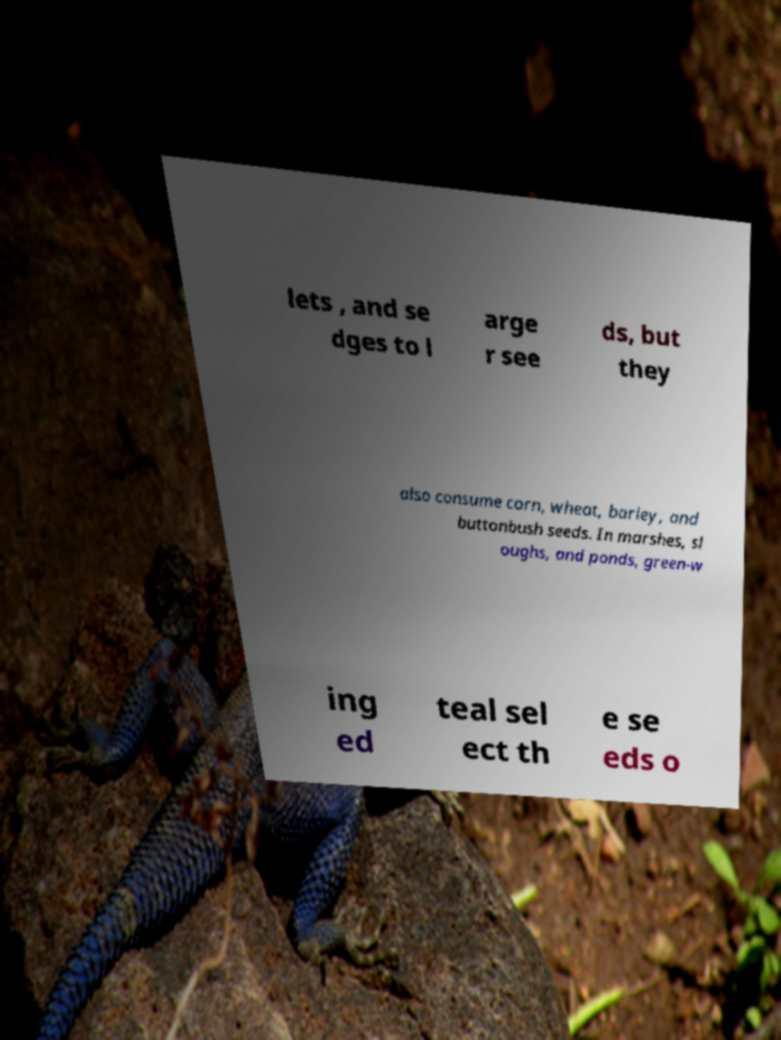Could you assist in decoding the text presented in this image and type it out clearly? lets , and se dges to l arge r see ds, but they also consume corn, wheat, barley, and buttonbush seeds. In marshes, sl oughs, and ponds, green-w ing ed teal sel ect th e se eds o 